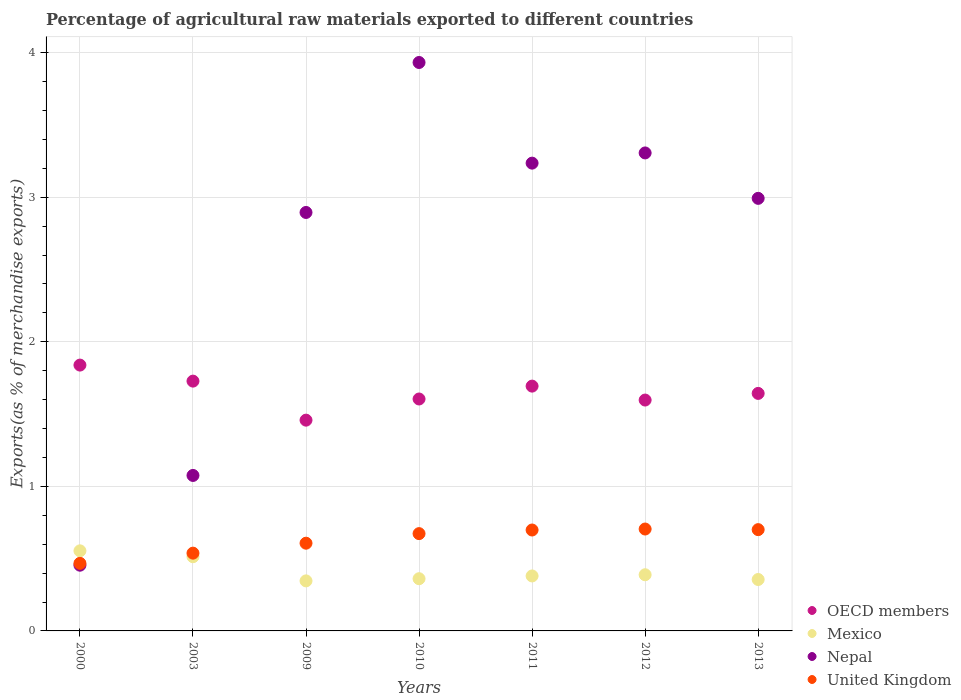What is the percentage of exports to different countries in United Kingdom in 2000?
Your answer should be compact. 0.47. Across all years, what is the maximum percentage of exports to different countries in OECD members?
Give a very brief answer. 1.84. Across all years, what is the minimum percentage of exports to different countries in OECD members?
Offer a terse response. 1.46. What is the total percentage of exports to different countries in Nepal in the graph?
Your answer should be compact. 17.89. What is the difference between the percentage of exports to different countries in United Kingdom in 2010 and that in 2011?
Give a very brief answer. -0.03. What is the difference between the percentage of exports to different countries in OECD members in 2000 and the percentage of exports to different countries in Nepal in 2012?
Offer a terse response. -1.47. What is the average percentage of exports to different countries in United Kingdom per year?
Offer a very short reply. 0.63. In the year 2010, what is the difference between the percentage of exports to different countries in Nepal and percentage of exports to different countries in OECD members?
Offer a terse response. 2.33. In how many years, is the percentage of exports to different countries in Mexico greater than 3.2 %?
Keep it short and to the point. 0. What is the ratio of the percentage of exports to different countries in United Kingdom in 2000 to that in 2011?
Make the answer very short. 0.67. Is the percentage of exports to different countries in United Kingdom in 2009 less than that in 2011?
Offer a terse response. Yes. Is the difference between the percentage of exports to different countries in Nepal in 2003 and 2010 greater than the difference between the percentage of exports to different countries in OECD members in 2003 and 2010?
Offer a terse response. No. What is the difference between the highest and the second highest percentage of exports to different countries in United Kingdom?
Give a very brief answer. 0. What is the difference between the highest and the lowest percentage of exports to different countries in United Kingdom?
Provide a succinct answer. 0.24. How many dotlines are there?
Your answer should be compact. 4. How many years are there in the graph?
Offer a terse response. 7. What is the difference between two consecutive major ticks on the Y-axis?
Provide a succinct answer. 1. Does the graph contain grids?
Keep it short and to the point. Yes. Where does the legend appear in the graph?
Ensure brevity in your answer.  Bottom right. What is the title of the graph?
Your response must be concise. Percentage of agricultural raw materials exported to different countries. Does "Bahrain" appear as one of the legend labels in the graph?
Your response must be concise. No. What is the label or title of the X-axis?
Provide a succinct answer. Years. What is the label or title of the Y-axis?
Your answer should be very brief. Exports(as % of merchandise exports). What is the Exports(as % of merchandise exports) in OECD members in 2000?
Offer a very short reply. 1.84. What is the Exports(as % of merchandise exports) of Mexico in 2000?
Your answer should be compact. 0.55. What is the Exports(as % of merchandise exports) of Nepal in 2000?
Your answer should be very brief. 0.45. What is the Exports(as % of merchandise exports) of United Kingdom in 2000?
Your answer should be very brief. 0.47. What is the Exports(as % of merchandise exports) of OECD members in 2003?
Give a very brief answer. 1.73. What is the Exports(as % of merchandise exports) of Mexico in 2003?
Provide a succinct answer. 0.51. What is the Exports(as % of merchandise exports) of Nepal in 2003?
Ensure brevity in your answer.  1.08. What is the Exports(as % of merchandise exports) of United Kingdom in 2003?
Your answer should be very brief. 0.54. What is the Exports(as % of merchandise exports) of OECD members in 2009?
Offer a terse response. 1.46. What is the Exports(as % of merchandise exports) of Mexico in 2009?
Provide a succinct answer. 0.35. What is the Exports(as % of merchandise exports) in Nepal in 2009?
Make the answer very short. 2.89. What is the Exports(as % of merchandise exports) in United Kingdom in 2009?
Give a very brief answer. 0.61. What is the Exports(as % of merchandise exports) of OECD members in 2010?
Keep it short and to the point. 1.6. What is the Exports(as % of merchandise exports) of Mexico in 2010?
Your answer should be compact. 0.36. What is the Exports(as % of merchandise exports) of Nepal in 2010?
Keep it short and to the point. 3.93. What is the Exports(as % of merchandise exports) of United Kingdom in 2010?
Your response must be concise. 0.67. What is the Exports(as % of merchandise exports) of OECD members in 2011?
Ensure brevity in your answer.  1.69. What is the Exports(as % of merchandise exports) of Mexico in 2011?
Your answer should be compact. 0.38. What is the Exports(as % of merchandise exports) in Nepal in 2011?
Make the answer very short. 3.24. What is the Exports(as % of merchandise exports) of United Kingdom in 2011?
Ensure brevity in your answer.  0.7. What is the Exports(as % of merchandise exports) in OECD members in 2012?
Ensure brevity in your answer.  1.6. What is the Exports(as % of merchandise exports) of Mexico in 2012?
Your answer should be very brief. 0.39. What is the Exports(as % of merchandise exports) in Nepal in 2012?
Keep it short and to the point. 3.31. What is the Exports(as % of merchandise exports) in United Kingdom in 2012?
Your answer should be very brief. 0.7. What is the Exports(as % of merchandise exports) of OECD members in 2013?
Keep it short and to the point. 1.64. What is the Exports(as % of merchandise exports) of Mexico in 2013?
Offer a terse response. 0.36. What is the Exports(as % of merchandise exports) in Nepal in 2013?
Provide a short and direct response. 2.99. What is the Exports(as % of merchandise exports) of United Kingdom in 2013?
Give a very brief answer. 0.7. Across all years, what is the maximum Exports(as % of merchandise exports) of OECD members?
Keep it short and to the point. 1.84. Across all years, what is the maximum Exports(as % of merchandise exports) in Mexico?
Make the answer very short. 0.55. Across all years, what is the maximum Exports(as % of merchandise exports) of Nepal?
Provide a succinct answer. 3.93. Across all years, what is the maximum Exports(as % of merchandise exports) of United Kingdom?
Give a very brief answer. 0.7. Across all years, what is the minimum Exports(as % of merchandise exports) of OECD members?
Offer a very short reply. 1.46. Across all years, what is the minimum Exports(as % of merchandise exports) in Mexico?
Offer a very short reply. 0.35. Across all years, what is the minimum Exports(as % of merchandise exports) of Nepal?
Keep it short and to the point. 0.45. Across all years, what is the minimum Exports(as % of merchandise exports) of United Kingdom?
Your answer should be very brief. 0.47. What is the total Exports(as % of merchandise exports) in OECD members in the graph?
Ensure brevity in your answer.  11.56. What is the total Exports(as % of merchandise exports) of Mexico in the graph?
Provide a short and direct response. 2.9. What is the total Exports(as % of merchandise exports) in Nepal in the graph?
Your response must be concise. 17.89. What is the total Exports(as % of merchandise exports) of United Kingdom in the graph?
Your response must be concise. 4.39. What is the difference between the Exports(as % of merchandise exports) in OECD members in 2000 and that in 2003?
Offer a terse response. 0.11. What is the difference between the Exports(as % of merchandise exports) in Mexico in 2000 and that in 2003?
Offer a very short reply. 0.04. What is the difference between the Exports(as % of merchandise exports) of Nepal in 2000 and that in 2003?
Your response must be concise. -0.62. What is the difference between the Exports(as % of merchandise exports) in United Kingdom in 2000 and that in 2003?
Offer a very short reply. -0.07. What is the difference between the Exports(as % of merchandise exports) of OECD members in 2000 and that in 2009?
Ensure brevity in your answer.  0.38. What is the difference between the Exports(as % of merchandise exports) of Mexico in 2000 and that in 2009?
Provide a succinct answer. 0.21. What is the difference between the Exports(as % of merchandise exports) in Nepal in 2000 and that in 2009?
Give a very brief answer. -2.44. What is the difference between the Exports(as % of merchandise exports) of United Kingdom in 2000 and that in 2009?
Provide a succinct answer. -0.14. What is the difference between the Exports(as % of merchandise exports) in OECD members in 2000 and that in 2010?
Ensure brevity in your answer.  0.23. What is the difference between the Exports(as % of merchandise exports) in Mexico in 2000 and that in 2010?
Make the answer very short. 0.19. What is the difference between the Exports(as % of merchandise exports) in Nepal in 2000 and that in 2010?
Your response must be concise. -3.48. What is the difference between the Exports(as % of merchandise exports) of United Kingdom in 2000 and that in 2010?
Keep it short and to the point. -0.21. What is the difference between the Exports(as % of merchandise exports) in OECD members in 2000 and that in 2011?
Offer a terse response. 0.15. What is the difference between the Exports(as % of merchandise exports) in Mexico in 2000 and that in 2011?
Your answer should be compact. 0.17. What is the difference between the Exports(as % of merchandise exports) of Nepal in 2000 and that in 2011?
Provide a succinct answer. -2.78. What is the difference between the Exports(as % of merchandise exports) in United Kingdom in 2000 and that in 2011?
Provide a short and direct response. -0.23. What is the difference between the Exports(as % of merchandise exports) of OECD members in 2000 and that in 2012?
Offer a terse response. 0.24. What is the difference between the Exports(as % of merchandise exports) in Mexico in 2000 and that in 2012?
Give a very brief answer. 0.17. What is the difference between the Exports(as % of merchandise exports) in Nepal in 2000 and that in 2012?
Your response must be concise. -2.85. What is the difference between the Exports(as % of merchandise exports) of United Kingdom in 2000 and that in 2012?
Offer a very short reply. -0.24. What is the difference between the Exports(as % of merchandise exports) in OECD members in 2000 and that in 2013?
Offer a very short reply. 0.2. What is the difference between the Exports(as % of merchandise exports) of Mexico in 2000 and that in 2013?
Offer a very short reply. 0.2. What is the difference between the Exports(as % of merchandise exports) of Nepal in 2000 and that in 2013?
Keep it short and to the point. -2.54. What is the difference between the Exports(as % of merchandise exports) in United Kingdom in 2000 and that in 2013?
Offer a terse response. -0.23. What is the difference between the Exports(as % of merchandise exports) of OECD members in 2003 and that in 2009?
Offer a terse response. 0.27. What is the difference between the Exports(as % of merchandise exports) in Mexico in 2003 and that in 2009?
Your answer should be compact. 0.17. What is the difference between the Exports(as % of merchandise exports) of Nepal in 2003 and that in 2009?
Offer a terse response. -1.82. What is the difference between the Exports(as % of merchandise exports) of United Kingdom in 2003 and that in 2009?
Provide a succinct answer. -0.07. What is the difference between the Exports(as % of merchandise exports) in OECD members in 2003 and that in 2010?
Your response must be concise. 0.12. What is the difference between the Exports(as % of merchandise exports) of Mexico in 2003 and that in 2010?
Ensure brevity in your answer.  0.15. What is the difference between the Exports(as % of merchandise exports) of Nepal in 2003 and that in 2010?
Your response must be concise. -2.86. What is the difference between the Exports(as % of merchandise exports) of United Kingdom in 2003 and that in 2010?
Provide a short and direct response. -0.14. What is the difference between the Exports(as % of merchandise exports) of OECD members in 2003 and that in 2011?
Provide a succinct answer. 0.03. What is the difference between the Exports(as % of merchandise exports) in Mexico in 2003 and that in 2011?
Offer a terse response. 0.13. What is the difference between the Exports(as % of merchandise exports) of Nepal in 2003 and that in 2011?
Provide a short and direct response. -2.16. What is the difference between the Exports(as % of merchandise exports) in United Kingdom in 2003 and that in 2011?
Keep it short and to the point. -0.16. What is the difference between the Exports(as % of merchandise exports) in OECD members in 2003 and that in 2012?
Make the answer very short. 0.13. What is the difference between the Exports(as % of merchandise exports) of Mexico in 2003 and that in 2012?
Your answer should be very brief. 0.12. What is the difference between the Exports(as % of merchandise exports) in Nepal in 2003 and that in 2012?
Your answer should be compact. -2.23. What is the difference between the Exports(as % of merchandise exports) in United Kingdom in 2003 and that in 2012?
Your answer should be very brief. -0.17. What is the difference between the Exports(as % of merchandise exports) in OECD members in 2003 and that in 2013?
Your response must be concise. 0.09. What is the difference between the Exports(as % of merchandise exports) of Mexico in 2003 and that in 2013?
Give a very brief answer. 0.16. What is the difference between the Exports(as % of merchandise exports) in Nepal in 2003 and that in 2013?
Offer a terse response. -1.92. What is the difference between the Exports(as % of merchandise exports) in United Kingdom in 2003 and that in 2013?
Provide a succinct answer. -0.16. What is the difference between the Exports(as % of merchandise exports) of OECD members in 2009 and that in 2010?
Give a very brief answer. -0.15. What is the difference between the Exports(as % of merchandise exports) in Mexico in 2009 and that in 2010?
Ensure brevity in your answer.  -0.01. What is the difference between the Exports(as % of merchandise exports) in Nepal in 2009 and that in 2010?
Give a very brief answer. -1.04. What is the difference between the Exports(as % of merchandise exports) in United Kingdom in 2009 and that in 2010?
Offer a terse response. -0.07. What is the difference between the Exports(as % of merchandise exports) in OECD members in 2009 and that in 2011?
Provide a short and direct response. -0.24. What is the difference between the Exports(as % of merchandise exports) of Mexico in 2009 and that in 2011?
Give a very brief answer. -0.03. What is the difference between the Exports(as % of merchandise exports) in Nepal in 2009 and that in 2011?
Keep it short and to the point. -0.34. What is the difference between the Exports(as % of merchandise exports) in United Kingdom in 2009 and that in 2011?
Offer a terse response. -0.09. What is the difference between the Exports(as % of merchandise exports) of OECD members in 2009 and that in 2012?
Provide a short and direct response. -0.14. What is the difference between the Exports(as % of merchandise exports) in Mexico in 2009 and that in 2012?
Keep it short and to the point. -0.04. What is the difference between the Exports(as % of merchandise exports) of Nepal in 2009 and that in 2012?
Offer a very short reply. -0.41. What is the difference between the Exports(as % of merchandise exports) in United Kingdom in 2009 and that in 2012?
Make the answer very short. -0.1. What is the difference between the Exports(as % of merchandise exports) in OECD members in 2009 and that in 2013?
Offer a very short reply. -0.18. What is the difference between the Exports(as % of merchandise exports) of Mexico in 2009 and that in 2013?
Provide a short and direct response. -0.01. What is the difference between the Exports(as % of merchandise exports) of Nepal in 2009 and that in 2013?
Your answer should be very brief. -0.1. What is the difference between the Exports(as % of merchandise exports) of United Kingdom in 2009 and that in 2013?
Keep it short and to the point. -0.09. What is the difference between the Exports(as % of merchandise exports) in OECD members in 2010 and that in 2011?
Provide a short and direct response. -0.09. What is the difference between the Exports(as % of merchandise exports) in Mexico in 2010 and that in 2011?
Provide a succinct answer. -0.02. What is the difference between the Exports(as % of merchandise exports) of Nepal in 2010 and that in 2011?
Ensure brevity in your answer.  0.7. What is the difference between the Exports(as % of merchandise exports) in United Kingdom in 2010 and that in 2011?
Keep it short and to the point. -0.03. What is the difference between the Exports(as % of merchandise exports) in OECD members in 2010 and that in 2012?
Your response must be concise. 0.01. What is the difference between the Exports(as % of merchandise exports) in Mexico in 2010 and that in 2012?
Your response must be concise. -0.03. What is the difference between the Exports(as % of merchandise exports) of Nepal in 2010 and that in 2012?
Provide a succinct answer. 0.63. What is the difference between the Exports(as % of merchandise exports) in United Kingdom in 2010 and that in 2012?
Provide a short and direct response. -0.03. What is the difference between the Exports(as % of merchandise exports) in OECD members in 2010 and that in 2013?
Make the answer very short. -0.04. What is the difference between the Exports(as % of merchandise exports) of Mexico in 2010 and that in 2013?
Make the answer very short. 0.01. What is the difference between the Exports(as % of merchandise exports) in Nepal in 2010 and that in 2013?
Your response must be concise. 0.94. What is the difference between the Exports(as % of merchandise exports) of United Kingdom in 2010 and that in 2013?
Ensure brevity in your answer.  -0.03. What is the difference between the Exports(as % of merchandise exports) of OECD members in 2011 and that in 2012?
Your answer should be compact. 0.1. What is the difference between the Exports(as % of merchandise exports) in Mexico in 2011 and that in 2012?
Offer a very short reply. -0.01. What is the difference between the Exports(as % of merchandise exports) of Nepal in 2011 and that in 2012?
Provide a short and direct response. -0.07. What is the difference between the Exports(as % of merchandise exports) in United Kingdom in 2011 and that in 2012?
Offer a terse response. -0.01. What is the difference between the Exports(as % of merchandise exports) in OECD members in 2011 and that in 2013?
Your response must be concise. 0.05. What is the difference between the Exports(as % of merchandise exports) in Mexico in 2011 and that in 2013?
Your answer should be very brief. 0.02. What is the difference between the Exports(as % of merchandise exports) in Nepal in 2011 and that in 2013?
Make the answer very short. 0.24. What is the difference between the Exports(as % of merchandise exports) in United Kingdom in 2011 and that in 2013?
Give a very brief answer. -0. What is the difference between the Exports(as % of merchandise exports) in OECD members in 2012 and that in 2013?
Give a very brief answer. -0.05. What is the difference between the Exports(as % of merchandise exports) in Mexico in 2012 and that in 2013?
Your response must be concise. 0.03. What is the difference between the Exports(as % of merchandise exports) in Nepal in 2012 and that in 2013?
Your answer should be very brief. 0.31. What is the difference between the Exports(as % of merchandise exports) of United Kingdom in 2012 and that in 2013?
Your response must be concise. 0. What is the difference between the Exports(as % of merchandise exports) of OECD members in 2000 and the Exports(as % of merchandise exports) of Mexico in 2003?
Your answer should be very brief. 1.33. What is the difference between the Exports(as % of merchandise exports) in OECD members in 2000 and the Exports(as % of merchandise exports) in Nepal in 2003?
Offer a terse response. 0.76. What is the difference between the Exports(as % of merchandise exports) in OECD members in 2000 and the Exports(as % of merchandise exports) in United Kingdom in 2003?
Offer a terse response. 1.3. What is the difference between the Exports(as % of merchandise exports) in Mexico in 2000 and the Exports(as % of merchandise exports) in Nepal in 2003?
Give a very brief answer. -0.52. What is the difference between the Exports(as % of merchandise exports) in Mexico in 2000 and the Exports(as % of merchandise exports) in United Kingdom in 2003?
Your answer should be compact. 0.02. What is the difference between the Exports(as % of merchandise exports) in Nepal in 2000 and the Exports(as % of merchandise exports) in United Kingdom in 2003?
Provide a succinct answer. -0.08. What is the difference between the Exports(as % of merchandise exports) in OECD members in 2000 and the Exports(as % of merchandise exports) in Mexico in 2009?
Your answer should be compact. 1.49. What is the difference between the Exports(as % of merchandise exports) in OECD members in 2000 and the Exports(as % of merchandise exports) in Nepal in 2009?
Ensure brevity in your answer.  -1.06. What is the difference between the Exports(as % of merchandise exports) of OECD members in 2000 and the Exports(as % of merchandise exports) of United Kingdom in 2009?
Provide a succinct answer. 1.23. What is the difference between the Exports(as % of merchandise exports) in Mexico in 2000 and the Exports(as % of merchandise exports) in Nepal in 2009?
Give a very brief answer. -2.34. What is the difference between the Exports(as % of merchandise exports) of Mexico in 2000 and the Exports(as % of merchandise exports) of United Kingdom in 2009?
Your response must be concise. -0.05. What is the difference between the Exports(as % of merchandise exports) of Nepal in 2000 and the Exports(as % of merchandise exports) of United Kingdom in 2009?
Provide a succinct answer. -0.15. What is the difference between the Exports(as % of merchandise exports) of OECD members in 2000 and the Exports(as % of merchandise exports) of Mexico in 2010?
Provide a succinct answer. 1.48. What is the difference between the Exports(as % of merchandise exports) of OECD members in 2000 and the Exports(as % of merchandise exports) of Nepal in 2010?
Your answer should be compact. -2.09. What is the difference between the Exports(as % of merchandise exports) in OECD members in 2000 and the Exports(as % of merchandise exports) in United Kingdom in 2010?
Keep it short and to the point. 1.17. What is the difference between the Exports(as % of merchandise exports) of Mexico in 2000 and the Exports(as % of merchandise exports) of Nepal in 2010?
Ensure brevity in your answer.  -3.38. What is the difference between the Exports(as % of merchandise exports) of Mexico in 2000 and the Exports(as % of merchandise exports) of United Kingdom in 2010?
Your answer should be compact. -0.12. What is the difference between the Exports(as % of merchandise exports) of Nepal in 2000 and the Exports(as % of merchandise exports) of United Kingdom in 2010?
Your response must be concise. -0.22. What is the difference between the Exports(as % of merchandise exports) of OECD members in 2000 and the Exports(as % of merchandise exports) of Mexico in 2011?
Provide a succinct answer. 1.46. What is the difference between the Exports(as % of merchandise exports) in OECD members in 2000 and the Exports(as % of merchandise exports) in Nepal in 2011?
Make the answer very short. -1.4. What is the difference between the Exports(as % of merchandise exports) in OECD members in 2000 and the Exports(as % of merchandise exports) in United Kingdom in 2011?
Ensure brevity in your answer.  1.14. What is the difference between the Exports(as % of merchandise exports) of Mexico in 2000 and the Exports(as % of merchandise exports) of Nepal in 2011?
Offer a terse response. -2.68. What is the difference between the Exports(as % of merchandise exports) in Mexico in 2000 and the Exports(as % of merchandise exports) in United Kingdom in 2011?
Provide a succinct answer. -0.14. What is the difference between the Exports(as % of merchandise exports) of Nepal in 2000 and the Exports(as % of merchandise exports) of United Kingdom in 2011?
Offer a terse response. -0.24. What is the difference between the Exports(as % of merchandise exports) in OECD members in 2000 and the Exports(as % of merchandise exports) in Mexico in 2012?
Keep it short and to the point. 1.45. What is the difference between the Exports(as % of merchandise exports) of OECD members in 2000 and the Exports(as % of merchandise exports) of Nepal in 2012?
Make the answer very short. -1.47. What is the difference between the Exports(as % of merchandise exports) in OECD members in 2000 and the Exports(as % of merchandise exports) in United Kingdom in 2012?
Your answer should be very brief. 1.13. What is the difference between the Exports(as % of merchandise exports) in Mexico in 2000 and the Exports(as % of merchandise exports) in Nepal in 2012?
Offer a terse response. -2.75. What is the difference between the Exports(as % of merchandise exports) of Mexico in 2000 and the Exports(as % of merchandise exports) of United Kingdom in 2012?
Keep it short and to the point. -0.15. What is the difference between the Exports(as % of merchandise exports) in Nepal in 2000 and the Exports(as % of merchandise exports) in United Kingdom in 2012?
Provide a short and direct response. -0.25. What is the difference between the Exports(as % of merchandise exports) in OECD members in 2000 and the Exports(as % of merchandise exports) in Mexico in 2013?
Offer a terse response. 1.48. What is the difference between the Exports(as % of merchandise exports) in OECD members in 2000 and the Exports(as % of merchandise exports) in Nepal in 2013?
Your response must be concise. -1.15. What is the difference between the Exports(as % of merchandise exports) in OECD members in 2000 and the Exports(as % of merchandise exports) in United Kingdom in 2013?
Offer a terse response. 1.14. What is the difference between the Exports(as % of merchandise exports) in Mexico in 2000 and the Exports(as % of merchandise exports) in Nepal in 2013?
Provide a succinct answer. -2.44. What is the difference between the Exports(as % of merchandise exports) of Mexico in 2000 and the Exports(as % of merchandise exports) of United Kingdom in 2013?
Provide a succinct answer. -0.15. What is the difference between the Exports(as % of merchandise exports) of Nepal in 2000 and the Exports(as % of merchandise exports) of United Kingdom in 2013?
Your response must be concise. -0.25. What is the difference between the Exports(as % of merchandise exports) in OECD members in 2003 and the Exports(as % of merchandise exports) in Mexico in 2009?
Your answer should be compact. 1.38. What is the difference between the Exports(as % of merchandise exports) in OECD members in 2003 and the Exports(as % of merchandise exports) in Nepal in 2009?
Keep it short and to the point. -1.17. What is the difference between the Exports(as % of merchandise exports) of OECD members in 2003 and the Exports(as % of merchandise exports) of United Kingdom in 2009?
Give a very brief answer. 1.12. What is the difference between the Exports(as % of merchandise exports) of Mexico in 2003 and the Exports(as % of merchandise exports) of Nepal in 2009?
Your answer should be compact. -2.38. What is the difference between the Exports(as % of merchandise exports) of Mexico in 2003 and the Exports(as % of merchandise exports) of United Kingdom in 2009?
Your answer should be compact. -0.09. What is the difference between the Exports(as % of merchandise exports) of Nepal in 2003 and the Exports(as % of merchandise exports) of United Kingdom in 2009?
Make the answer very short. 0.47. What is the difference between the Exports(as % of merchandise exports) in OECD members in 2003 and the Exports(as % of merchandise exports) in Mexico in 2010?
Give a very brief answer. 1.37. What is the difference between the Exports(as % of merchandise exports) in OECD members in 2003 and the Exports(as % of merchandise exports) in Nepal in 2010?
Ensure brevity in your answer.  -2.2. What is the difference between the Exports(as % of merchandise exports) in OECD members in 2003 and the Exports(as % of merchandise exports) in United Kingdom in 2010?
Provide a succinct answer. 1.05. What is the difference between the Exports(as % of merchandise exports) in Mexico in 2003 and the Exports(as % of merchandise exports) in Nepal in 2010?
Offer a very short reply. -3.42. What is the difference between the Exports(as % of merchandise exports) of Mexico in 2003 and the Exports(as % of merchandise exports) of United Kingdom in 2010?
Your response must be concise. -0.16. What is the difference between the Exports(as % of merchandise exports) of Nepal in 2003 and the Exports(as % of merchandise exports) of United Kingdom in 2010?
Provide a short and direct response. 0.4. What is the difference between the Exports(as % of merchandise exports) in OECD members in 2003 and the Exports(as % of merchandise exports) in Mexico in 2011?
Make the answer very short. 1.35. What is the difference between the Exports(as % of merchandise exports) of OECD members in 2003 and the Exports(as % of merchandise exports) of Nepal in 2011?
Your response must be concise. -1.51. What is the difference between the Exports(as % of merchandise exports) of OECD members in 2003 and the Exports(as % of merchandise exports) of United Kingdom in 2011?
Offer a terse response. 1.03. What is the difference between the Exports(as % of merchandise exports) of Mexico in 2003 and the Exports(as % of merchandise exports) of Nepal in 2011?
Make the answer very short. -2.72. What is the difference between the Exports(as % of merchandise exports) in Mexico in 2003 and the Exports(as % of merchandise exports) in United Kingdom in 2011?
Provide a short and direct response. -0.18. What is the difference between the Exports(as % of merchandise exports) of Nepal in 2003 and the Exports(as % of merchandise exports) of United Kingdom in 2011?
Your answer should be very brief. 0.38. What is the difference between the Exports(as % of merchandise exports) in OECD members in 2003 and the Exports(as % of merchandise exports) in Mexico in 2012?
Provide a succinct answer. 1.34. What is the difference between the Exports(as % of merchandise exports) of OECD members in 2003 and the Exports(as % of merchandise exports) of Nepal in 2012?
Your answer should be compact. -1.58. What is the difference between the Exports(as % of merchandise exports) of OECD members in 2003 and the Exports(as % of merchandise exports) of United Kingdom in 2012?
Make the answer very short. 1.02. What is the difference between the Exports(as % of merchandise exports) of Mexico in 2003 and the Exports(as % of merchandise exports) of Nepal in 2012?
Ensure brevity in your answer.  -2.79. What is the difference between the Exports(as % of merchandise exports) in Mexico in 2003 and the Exports(as % of merchandise exports) in United Kingdom in 2012?
Keep it short and to the point. -0.19. What is the difference between the Exports(as % of merchandise exports) in Nepal in 2003 and the Exports(as % of merchandise exports) in United Kingdom in 2012?
Give a very brief answer. 0.37. What is the difference between the Exports(as % of merchandise exports) in OECD members in 2003 and the Exports(as % of merchandise exports) in Mexico in 2013?
Offer a terse response. 1.37. What is the difference between the Exports(as % of merchandise exports) in OECD members in 2003 and the Exports(as % of merchandise exports) in Nepal in 2013?
Offer a very short reply. -1.26. What is the difference between the Exports(as % of merchandise exports) in OECD members in 2003 and the Exports(as % of merchandise exports) in United Kingdom in 2013?
Keep it short and to the point. 1.03. What is the difference between the Exports(as % of merchandise exports) in Mexico in 2003 and the Exports(as % of merchandise exports) in Nepal in 2013?
Give a very brief answer. -2.48. What is the difference between the Exports(as % of merchandise exports) in Mexico in 2003 and the Exports(as % of merchandise exports) in United Kingdom in 2013?
Make the answer very short. -0.19. What is the difference between the Exports(as % of merchandise exports) of Nepal in 2003 and the Exports(as % of merchandise exports) of United Kingdom in 2013?
Offer a very short reply. 0.37. What is the difference between the Exports(as % of merchandise exports) of OECD members in 2009 and the Exports(as % of merchandise exports) of Mexico in 2010?
Your response must be concise. 1.1. What is the difference between the Exports(as % of merchandise exports) in OECD members in 2009 and the Exports(as % of merchandise exports) in Nepal in 2010?
Provide a short and direct response. -2.47. What is the difference between the Exports(as % of merchandise exports) of OECD members in 2009 and the Exports(as % of merchandise exports) of United Kingdom in 2010?
Ensure brevity in your answer.  0.79. What is the difference between the Exports(as % of merchandise exports) in Mexico in 2009 and the Exports(as % of merchandise exports) in Nepal in 2010?
Provide a succinct answer. -3.59. What is the difference between the Exports(as % of merchandise exports) in Mexico in 2009 and the Exports(as % of merchandise exports) in United Kingdom in 2010?
Ensure brevity in your answer.  -0.33. What is the difference between the Exports(as % of merchandise exports) of Nepal in 2009 and the Exports(as % of merchandise exports) of United Kingdom in 2010?
Ensure brevity in your answer.  2.22. What is the difference between the Exports(as % of merchandise exports) of OECD members in 2009 and the Exports(as % of merchandise exports) of Mexico in 2011?
Your response must be concise. 1.08. What is the difference between the Exports(as % of merchandise exports) of OECD members in 2009 and the Exports(as % of merchandise exports) of Nepal in 2011?
Ensure brevity in your answer.  -1.78. What is the difference between the Exports(as % of merchandise exports) in OECD members in 2009 and the Exports(as % of merchandise exports) in United Kingdom in 2011?
Give a very brief answer. 0.76. What is the difference between the Exports(as % of merchandise exports) of Mexico in 2009 and the Exports(as % of merchandise exports) of Nepal in 2011?
Your answer should be very brief. -2.89. What is the difference between the Exports(as % of merchandise exports) in Mexico in 2009 and the Exports(as % of merchandise exports) in United Kingdom in 2011?
Give a very brief answer. -0.35. What is the difference between the Exports(as % of merchandise exports) in Nepal in 2009 and the Exports(as % of merchandise exports) in United Kingdom in 2011?
Ensure brevity in your answer.  2.2. What is the difference between the Exports(as % of merchandise exports) of OECD members in 2009 and the Exports(as % of merchandise exports) of Mexico in 2012?
Offer a terse response. 1.07. What is the difference between the Exports(as % of merchandise exports) of OECD members in 2009 and the Exports(as % of merchandise exports) of Nepal in 2012?
Make the answer very short. -1.85. What is the difference between the Exports(as % of merchandise exports) in OECD members in 2009 and the Exports(as % of merchandise exports) in United Kingdom in 2012?
Keep it short and to the point. 0.75. What is the difference between the Exports(as % of merchandise exports) in Mexico in 2009 and the Exports(as % of merchandise exports) in Nepal in 2012?
Your response must be concise. -2.96. What is the difference between the Exports(as % of merchandise exports) of Mexico in 2009 and the Exports(as % of merchandise exports) of United Kingdom in 2012?
Keep it short and to the point. -0.36. What is the difference between the Exports(as % of merchandise exports) of Nepal in 2009 and the Exports(as % of merchandise exports) of United Kingdom in 2012?
Your response must be concise. 2.19. What is the difference between the Exports(as % of merchandise exports) of OECD members in 2009 and the Exports(as % of merchandise exports) of Mexico in 2013?
Keep it short and to the point. 1.1. What is the difference between the Exports(as % of merchandise exports) of OECD members in 2009 and the Exports(as % of merchandise exports) of Nepal in 2013?
Offer a terse response. -1.53. What is the difference between the Exports(as % of merchandise exports) of OECD members in 2009 and the Exports(as % of merchandise exports) of United Kingdom in 2013?
Offer a very short reply. 0.76. What is the difference between the Exports(as % of merchandise exports) in Mexico in 2009 and the Exports(as % of merchandise exports) in Nepal in 2013?
Ensure brevity in your answer.  -2.65. What is the difference between the Exports(as % of merchandise exports) in Mexico in 2009 and the Exports(as % of merchandise exports) in United Kingdom in 2013?
Keep it short and to the point. -0.35. What is the difference between the Exports(as % of merchandise exports) in Nepal in 2009 and the Exports(as % of merchandise exports) in United Kingdom in 2013?
Offer a very short reply. 2.19. What is the difference between the Exports(as % of merchandise exports) in OECD members in 2010 and the Exports(as % of merchandise exports) in Mexico in 2011?
Provide a short and direct response. 1.22. What is the difference between the Exports(as % of merchandise exports) of OECD members in 2010 and the Exports(as % of merchandise exports) of Nepal in 2011?
Give a very brief answer. -1.63. What is the difference between the Exports(as % of merchandise exports) of OECD members in 2010 and the Exports(as % of merchandise exports) of United Kingdom in 2011?
Provide a succinct answer. 0.91. What is the difference between the Exports(as % of merchandise exports) of Mexico in 2010 and the Exports(as % of merchandise exports) of Nepal in 2011?
Ensure brevity in your answer.  -2.87. What is the difference between the Exports(as % of merchandise exports) in Mexico in 2010 and the Exports(as % of merchandise exports) in United Kingdom in 2011?
Your answer should be compact. -0.34. What is the difference between the Exports(as % of merchandise exports) in Nepal in 2010 and the Exports(as % of merchandise exports) in United Kingdom in 2011?
Offer a very short reply. 3.23. What is the difference between the Exports(as % of merchandise exports) of OECD members in 2010 and the Exports(as % of merchandise exports) of Mexico in 2012?
Provide a short and direct response. 1.22. What is the difference between the Exports(as % of merchandise exports) in OECD members in 2010 and the Exports(as % of merchandise exports) in Nepal in 2012?
Give a very brief answer. -1.7. What is the difference between the Exports(as % of merchandise exports) of OECD members in 2010 and the Exports(as % of merchandise exports) of United Kingdom in 2012?
Make the answer very short. 0.9. What is the difference between the Exports(as % of merchandise exports) of Mexico in 2010 and the Exports(as % of merchandise exports) of Nepal in 2012?
Keep it short and to the point. -2.95. What is the difference between the Exports(as % of merchandise exports) in Mexico in 2010 and the Exports(as % of merchandise exports) in United Kingdom in 2012?
Provide a succinct answer. -0.34. What is the difference between the Exports(as % of merchandise exports) in Nepal in 2010 and the Exports(as % of merchandise exports) in United Kingdom in 2012?
Give a very brief answer. 3.23. What is the difference between the Exports(as % of merchandise exports) in OECD members in 2010 and the Exports(as % of merchandise exports) in Mexico in 2013?
Your answer should be compact. 1.25. What is the difference between the Exports(as % of merchandise exports) in OECD members in 2010 and the Exports(as % of merchandise exports) in Nepal in 2013?
Provide a succinct answer. -1.39. What is the difference between the Exports(as % of merchandise exports) of OECD members in 2010 and the Exports(as % of merchandise exports) of United Kingdom in 2013?
Your answer should be very brief. 0.9. What is the difference between the Exports(as % of merchandise exports) of Mexico in 2010 and the Exports(as % of merchandise exports) of Nepal in 2013?
Provide a short and direct response. -2.63. What is the difference between the Exports(as % of merchandise exports) of Mexico in 2010 and the Exports(as % of merchandise exports) of United Kingdom in 2013?
Your answer should be very brief. -0.34. What is the difference between the Exports(as % of merchandise exports) in Nepal in 2010 and the Exports(as % of merchandise exports) in United Kingdom in 2013?
Keep it short and to the point. 3.23. What is the difference between the Exports(as % of merchandise exports) in OECD members in 2011 and the Exports(as % of merchandise exports) in Mexico in 2012?
Make the answer very short. 1.3. What is the difference between the Exports(as % of merchandise exports) of OECD members in 2011 and the Exports(as % of merchandise exports) of Nepal in 2012?
Make the answer very short. -1.61. What is the difference between the Exports(as % of merchandise exports) of Mexico in 2011 and the Exports(as % of merchandise exports) of Nepal in 2012?
Ensure brevity in your answer.  -2.93. What is the difference between the Exports(as % of merchandise exports) of Mexico in 2011 and the Exports(as % of merchandise exports) of United Kingdom in 2012?
Your answer should be compact. -0.32. What is the difference between the Exports(as % of merchandise exports) of Nepal in 2011 and the Exports(as % of merchandise exports) of United Kingdom in 2012?
Provide a succinct answer. 2.53. What is the difference between the Exports(as % of merchandise exports) of OECD members in 2011 and the Exports(as % of merchandise exports) of Mexico in 2013?
Provide a short and direct response. 1.34. What is the difference between the Exports(as % of merchandise exports) in OECD members in 2011 and the Exports(as % of merchandise exports) in Nepal in 2013?
Provide a short and direct response. -1.3. What is the difference between the Exports(as % of merchandise exports) in Mexico in 2011 and the Exports(as % of merchandise exports) in Nepal in 2013?
Your answer should be very brief. -2.61. What is the difference between the Exports(as % of merchandise exports) in Mexico in 2011 and the Exports(as % of merchandise exports) in United Kingdom in 2013?
Provide a succinct answer. -0.32. What is the difference between the Exports(as % of merchandise exports) in Nepal in 2011 and the Exports(as % of merchandise exports) in United Kingdom in 2013?
Your response must be concise. 2.54. What is the difference between the Exports(as % of merchandise exports) in OECD members in 2012 and the Exports(as % of merchandise exports) in Mexico in 2013?
Your response must be concise. 1.24. What is the difference between the Exports(as % of merchandise exports) of OECD members in 2012 and the Exports(as % of merchandise exports) of Nepal in 2013?
Offer a terse response. -1.4. What is the difference between the Exports(as % of merchandise exports) of OECD members in 2012 and the Exports(as % of merchandise exports) of United Kingdom in 2013?
Keep it short and to the point. 0.9. What is the difference between the Exports(as % of merchandise exports) in Mexico in 2012 and the Exports(as % of merchandise exports) in Nepal in 2013?
Offer a very short reply. -2.6. What is the difference between the Exports(as % of merchandise exports) of Mexico in 2012 and the Exports(as % of merchandise exports) of United Kingdom in 2013?
Ensure brevity in your answer.  -0.31. What is the difference between the Exports(as % of merchandise exports) of Nepal in 2012 and the Exports(as % of merchandise exports) of United Kingdom in 2013?
Ensure brevity in your answer.  2.61. What is the average Exports(as % of merchandise exports) in OECD members per year?
Keep it short and to the point. 1.65. What is the average Exports(as % of merchandise exports) in Mexico per year?
Offer a very short reply. 0.41. What is the average Exports(as % of merchandise exports) of Nepal per year?
Provide a succinct answer. 2.56. What is the average Exports(as % of merchandise exports) of United Kingdom per year?
Your answer should be very brief. 0.63. In the year 2000, what is the difference between the Exports(as % of merchandise exports) in OECD members and Exports(as % of merchandise exports) in Mexico?
Give a very brief answer. 1.28. In the year 2000, what is the difference between the Exports(as % of merchandise exports) of OECD members and Exports(as % of merchandise exports) of Nepal?
Provide a succinct answer. 1.38. In the year 2000, what is the difference between the Exports(as % of merchandise exports) of OECD members and Exports(as % of merchandise exports) of United Kingdom?
Offer a very short reply. 1.37. In the year 2000, what is the difference between the Exports(as % of merchandise exports) in Mexico and Exports(as % of merchandise exports) in Nepal?
Make the answer very short. 0.1. In the year 2000, what is the difference between the Exports(as % of merchandise exports) in Mexico and Exports(as % of merchandise exports) in United Kingdom?
Offer a terse response. 0.09. In the year 2000, what is the difference between the Exports(as % of merchandise exports) of Nepal and Exports(as % of merchandise exports) of United Kingdom?
Offer a very short reply. -0.01. In the year 2003, what is the difference between the Exports(as % of merchandise exports) of OECD members and Exports(as % of merchandise exports) of Mexico?
Provide a short and direct response. 1.21. In the year 2003, what is the difference between the Exports(as % of merchandise exports) in OECD members and Exports(as % of merchandise exports) in Nepal?
Your answer should be very brief. 0.65. In the year 2003, what is the difference between the Exports(as % of merchandise exports) of OECD members and Exports(as % of merchandise exports) of United Kingdom?
Give a very brief answer. 1.19. In the year 2003, what is the difference between the Exports(as % of merchandise exports) of Mexico and Exports(as % of merchandise exports) of Nepal?
Keep it short and to the point. -0.56. In the year 2003, what is the difference between the Exports(as % of merchandise exports) in Mexico and Exports(as % of merchandise exports) in United Kingdom?
Provide a short and direct response. -0.02. In the year 2003, what is the difference between the Exports(as % of merchandise exports) in Nepal and Exports(as % of merchandise exports) in United Kingdom?
Your response must be concise. 0.54. In the year 2009, what is the difference between the Exports(as % of merchandise exports) in OECD members and Exports(as % of merchandise exports) in Mexico?
Your answer should be compact. 1.11. In the year 2009, what is the difference between the Exports(as % of merchandise exports) in OECD members and Exports(as % of merchandise exports) in Nepal?
Make the answer very short. -1.44. In the year 2009, what is the difference between the Exports(as % of merchandise exports) of OECD members and Exports(as % of merchandise exports) of United Kingdom?
Make the answer very short. 0.85. In the year 2009, what is the difference between the Exports(as % of merchandise exports) in Mexico and Exports(as % of merchandise exports) in Nepal?
Keep it short and to the point. -2.55. In the year 2009, what is the difference between the Exports(as % of merchandise exports) of Mexico and Exports(as % of merchandise exports) of United Kingdom?
Make the answer very short. -0.26. In the year 2009, what is the difference between the Exports(as % of merchandise exports) of Nepal and Exports(as % of merchandise exports) of United Kingdom?
Make the answer very short. 2.29. In the year 2010, what is the difference between the Exports(as % of merchandise exports) of OECD members and Exports(as % of merchandise exports) of Mexico?
Offer a terse response. 1.24. In the year 2010, what is the difference between the Exports(as % of merchandise exports) in OECD members and Exports(as % of merchandise exports) in Nepal?
Offer a terse response. -2.33. In the year 2010, what is the difference between the Exports(as % of merchandise exports) of OECD members and Exports(as % of merchandise exports) of United Kingdom?
Provide a short and direct response. 0.93. In the year 2010, what is the difference between the Exports(as % of merchandise exports) of Mexico and Exports(as % of merchandise exports) of Nepal?
Provide a short and direct response. -3.57. In the year 2010, what is the difference between the Exports(as % of merchandise exports) of Mexico and Exports(as % of merchandise exports) of United Kingdom?
Ensure brevity in your answer.  -0.31. In the year 2010, what is the difference between the Exports(as % of merchandise exports) of Nepal and Exports(as % of merchandise exports) of United Kingdom?
Provide a short and direct response. 3.26. In the year 2011, what is the difference between the Exports(as % of merchandise exports) of OECD members and Exports(as % of merchandise exports) of Mexico?
Keep it short and to the point. 1.31. In the year 2011, what is the difference between the Exports(as % of merchandise exports) of OECD members and Exports(as % of merchandise exports) of Nepal?
Provide a short and direct response. -1.54. In the year 2011, what is the difference between the Exports(as % of merchandise exports) of OECD members and Exports(as % of merchandise exports) of United Kingdom?
Give a very brief answer. 1. In the year 2011, what is the difference between the Exports(as % of merchandise exports) in Mexico and Exports(as % of merchandise exports) in Nepal?
Your answer should be compact. -2.86. In the year 2011, what is the difference between the Exports(as % of merchandise exports) of Mexico and Exports(as % of merchandise exports) of United Kingdom?
Your response must be concise. -0.32. In the year 2011, what is the difference between the Exports(as % of merchandise exports) in Nepal and Exports(as % of merchandise exports) in United Kingdom?
Ensure brevity in your answer.  2.54. In the year 2012, what is the difference between the Exports(as % of merchandise exports) in OECD members and Exports(as % of merchandise exports) in Mexico?
Keep it short and to the point. 1.21. In the year 2012, what is the difference between the Exports(as % of merchandise exports) of OECD members and Exports(as % of merchandise exports) of Nepal?
Your answer should be compact. -1.71. In the year 2012, what is the difference between the Exports(as % of merchandise exports) in OECD members and Exports(as % of merchandise exports) in United Kingdom?
Your answer should be very brief. 0.89. In the year 2012, what is the difference between the Exports(as % of merchandise exports) of Mexico and Exports(as % of merchandise exports) of Nepal?
Keep it short and to the point. -2.92. In the year 2012, what is the difference between the Exports(as % of merchandise exports) in Mexico and Exports(as % of merchandise exports) in United Kingdom?
Provide a succinct answer. -0.32. In the year 2012, what is the difference between the Exports(as % of merchandise exports) in Nepal and Exports(as % of merchandise exports) in United Kingdom?
Make the answer very short. 2.6. In the year 2013, what is the difference between the Exports(as % of merchandise exports) of OECD members and Exports(as % of merchandise exports) of Mexico?
Your response must be concise. 1.29. In the year 2013, what is the difference between the Exports(as % of merchandise exports) in OECD members and Exports(as % of merchandise exports) in Nepal?
Keep it short and to the point. -1.35. In the year 2013, what is the difference between the Exports(as % of merchandise exports) of OECD members and Exports(as % of merchandise exports) of United Kingdom?
Your response must be concise. 0.94. In the year 2013, what is the difference between the Exports(as % of merchandise exports) of Mexico and Exports(as % of merchandise exports) of Nepal?
Your response must be concise. -2.64. In the year 2013, what is the difference between the Exports(as % of merchandise exports) of Mexico and Exports(as % of merchandise exports) of United Kingdom?
Keep it short and to the point. -0.34. In the year 2013, what is the difference between the Exports(as % of merchandise exports) of Nepal and Exports(as % of merchandise exports) of United Kingdom?
Ensure brevity in your answer.  2.29. What is the ratio of the Exports(as % of merchandise exports) in OECD members in 2000 to that in 2003?
Provide a succinct answer. 1.06. What is the ratio of the Exports(as % of merchandise exports) of Mexico in 2000 to that in 2003?
Keep it short and to the point. 1.08. What is the ratio of the Exports(as % of merchandise exports) of Nepal in 2000 to that in 2003?
Ensure brevity in your answer.  0.42. What is the ratio of the Exports(as % of merchandise exports) in United Kingdom in 2000 to that in 2003?
Provide a short and direct response. 0.87. What is the ratio of the Exports(as % of merchandise exports) of OECD members in 2000 to that in 2009?
Offer a very short reply. 1.26. What is the ratio of the Exports(as % of merchandise exports) of Mexico in 2000 to that in 2009?
Your response must be concise. 1.6. What is the ratio of the Exports(as % of merchandise exports) in Nepal in 2000 to that in 2009?
Your answer should be very brief. 0.16. What is the ratio of the Exports(as % of merchandise exports) in United Kingdom in 2000 to that in 2009?
Your answer should be very brief. 0.77. What is the ratio of the Exports(as % of merchandise exports) in OECD members in 2000 to that in 2010?
Give a very brief answer. 1.15. What is the ratio of the Exports(as % of merchandise exports) in Mexico in 2000 to that in 2010?
Provide a short and direct response. 1.53. What is the ratio of the Exports(as % of merchandise exports) in Nepal in 2000 to that in 2010?
Keep it short and to the point. 0.12. What is the ratio of the Exports(as % of merchandise exports) of United Kingdom in 2000 to that in 2010?
Your response must be concise. 0.69. What is the ratio of the Exports(as % of merchandise exports) in OECD members in 2000 to that in 2011?
Your answer should be very brief. 1.09. What is the ratio of the Exports(as % of merchandise exports) of Mexico in 2000 to that in 2011?
Make the answer very short. 1.46. What is the ratio of the Exports(as % of merchandise exports) in Nepal in 2000 to that in 2011?
Provide a short and direct response. 0.14. What is the ratio of the Exports(as % of merchandise exports) of United Kingdom in 2000 to that in 2011?
Give a very brief answer. 0.67. What is the ratio of the Exports(as % of merchandise exports) of OECD members in 2000 to that in 2012?
Provide a short and direct response. 1.15. What is the ratio of the Exports(as % of merchandise exports) in Mexico in 2000 to that in 2012?
Make the answer very short. 1.43. What is the ratio of the Exports(as % of merchandise exports) of Nepal in 2000 to that in 2012?
Keep it short and to the point. 0.14. What is the ratio of the Exports(as % of merchandise exports) of United Kingdom in 2000 to that in 2012?
Give a very brief answer. 0.66. What is the ratio of the Exports(as % of merchandise exports) of OECD members in 2000 to that in 2013?
Provide a succinct answer. 1.12. What is the ratio of the Exports(as % of merchandise exports) of Mexico in 2000 to that in 2013?
Your response must be concise. 1.56. What is the ratio of the Exports(as % of merchandise exports) of Nepal in 2000 to that in 2013?
Give a very brief answer. 0.15. What is the ratio of the Exports(as % of merchandise exports) in United Kingdom in 2000 to that in 2013?
Offer a terse response. 0.67. What is the ratio of the Exports(as % of merchandise exports) of OECD members in 2003 to that in 2009?
Your answer should be very brief. 1.19. What is the ratio of the Exports(as % of merchandise exports) in Mexico in 2003 to that in 2009?
Make the answer very short. 1.48. What is the ratio of the Exports(as % of merchandise exports) in Nepal in 2003 to that in 2009?
Provide a succinct answer. 0.37. What is the ratio of the Exports(as % of merchandise exports) of United Kingdom in 2003 to that in 2009?
Ensure brevity in your answer.  0.89. What is the ratio of the Exports(as % of merchandise exports) of OECD members in 2003 to that in 2010?
Your answer should be very brief. 1.08. What is the ratio of the Exports(as % of merchandise exports) of Mexico in 2003 to that in 2010?
Your answer should be very brief. 1.42. What is the ratio of the Exports(as % of merchandise exports) in Nepal in 2003 to that in 2010?
Your answer should be compact. 0.27. What is the ratio of the Exports(as % of merchandise exports) in United Kingdom in 2003 to that in 2010?
Provide a short and direct response. 0.8. What is the ratio of the Exports(as % of merchandise exports) in OECD members in 2003 to that in 2011?
Make the answer very short. 1.02. What is the ratio of the Exports(as % of merchandise exports) of Mexico in 2003 to that in 2011?
Your answer should be very brief. 1.35. What is the ratio of the Exports(as % of merchandise exports) of Nepal in 2003 to that in 2011?
Offer a terse response. 0.33. What is the ratio of the Exports(as % of merchandise exports) in United Kingdom in 2003 to that in 2011?
Your answer should be very brief. 0.77. What is the ratio of the Exports(as % of merchandise exports) in OECD members in 2003 to that in 2012?
Your response must be concise. 1.08. What is the ratio of the Exports(as % of merchandise exports) in Mexico in 2003 to that in 2012?
Make the answer very short. 1.32. What is the ratio of the Exports(as % of merchandise exports) of Nepal in 2003 to that in 2012?
Give a very brief answer. 0.33. What is the ratio of the Exports(as % of merchandise exports) of United Kingdom in 2003 to that in 2012?
Give a very brief answer. 0.76. What is the ratio of the Exports(as % of merchandise exports) in OECD members in 2003 to that in 2013?
Ensure brevity in your answer.  1.05. What is the ratio of the Exports(as % of merchandise exports) of Mexico in 2003 to that in 2013?
Ensure brevity in your answer.  1.44. What is the ratio of the Exports(as % of merchandise exports) of Nepal in 2003 to that in 2013?
Provide a succinct answer. 0.36. What is the ratio of the Exports(as % of merchandise exports) in United Kingdom in 2003 to that in 2013?
Your answer should be compact. 0.77. What is the ratio of the Exports(as % of merchandise exports) in OECD members in 2009 to that in 2010?
Your answer should be very brief. 0.91. What is the ratio of the Exports(as % of merchandise exports) in Mexico in 2009 to that in 2010?
Keep it short and to the point. 0.96. What is the ratio of the Exports(as % of merchandise exports) of Nepal in 2009 to that in 2010?
Provide a short and direct response. 0.74. What is the ratio of the Exports(as % of merchandise exports) in United Kingdom in 2009 to that in 2010?
Your response must be concise. 0.9. What is the ratio of the Exports(as % of merchandise exports) in OECD members in 2009 to that in 2011?
Your answer should be compact. 0.86. What is the ratio of the Exports(as % of merchandise exports) in Mexico in 2009 to that in 2011?
Keep it short and to the point. 0.91. What is the ratio of the Exports(as % of merchandise exports) of Nepal in 2009 to that in 2011?
Your response must be concise. 0.89. What is the ratio of the Exports(as % of merchandise exports) of United Kingdom in 2009 to that in 2011?
Give a very brief answer. 0.87. What is the ratio of the Exports(as % of merchandise exports) of OECD members in 2009 to that in 2012?
Provide a short and direct response. 0.91. What is the ratio of the Exports(as % of merchandise exports) in Mexico in 2009 to that in 2012?
Offer a terse response. 0.89. What is the ratio of the Exports(as % of merchandise exports) in Nepal in 2009 to that in 2012?
Give a very brief answer. 0.88. What is the ratio of the Exports(as % of merchandise exports) of United Kingdom in 2009 to that in 2012?
Give a very brief answer. 0.86. What is the ratio of the Exports(as % of merchandise exports) in OECD members in 2009 to that in 2013?
Keep it short and to the point. 0.89. What is the ratio of the Exports(as % of merchandise exports) of Mexico in 2009 to that in 2013?
Your answer should be compact. 0.97. What is the ratio of the Exports(as % of merchandise exports) of Nepal in 2009 to that in 2013?
Keep it short and to the point. 0.97. What is the ratio of the Exports(as % of merchandise exports) in United Kingdom in 2009 to that in 2013?
Your answer should be very brief. 0.87. What is the ratio of the Exports(as % of merchandise exports) of OECD members in 2010 to that in 2011?
Your answer should be very brief. 0.95. What is the ratio of the Exports(as % of merchandise exports) of Mexico in 2010 to that in 2011?
Make the answer very short. 0.95. What is the ratio of the Exports(as % of merchandise exports) in Nepal in 2010 to that in 2011?
Ensure brevity in your answer.  1.22. What is the ratio of the Exports(as % of merchandise exports) of United Kingdom in 2010 to that in 2011?
Give a very brief answer. 0.96. What is the ratio of the Exports(as % of merchandise exports) of OECD members in 2010 to that in 2012?
Your answer should be compact. 1. What is the ratio of the Exports(as % of merchandise exports) in Mexico in 2010 to that in 2012?
Ensure brevity in your answer.  0.93. What is the ratio of the Exports(as % of merchandise exports) in Nepal in 2010 to that in 2012?
Your answer should be compact. 1.19. What is the ratio of the Exports(as % of merchandise exports) of United Kingdom in 2010 to that in 2012?
Give a very brief answer. 0.95. What is the ratio of the Exports(as % of merchandise exports) in OECD members in 2010 to that in 2013?
Give a very brief answer. 0.98. What is the ratio of the Exports(as % of merchandise exports) in Mexico in 2010 to that in 2013?
Offer a very short reply. 1.02. What is the ratio of the Exports(as % of merchandise exports) of Nepal in 2010 to that in 2013?
Your answer should be compact. 1.31. What is the ratio of the Exports(as % of merchandise exports) of United Kingdom in 2010 to that in 2013?
Give a very brief answer. 0.96. What is the ratio of the Exports(as % of merchandise exports) in OECD members in 2011 to that in 2012?
Provide a succinct answer. 1.06. What is the ratio of the Exports(as % of merchandise exports) of Mexico in 2011 to that in 2012?
Offer a very short reply. 0.98. What is the ratio of the Exports(as % of merchandise exports) in Nepal in 2011 to that in 2012?
Your answer should be compact. 0.98. What is the ratio of the Exports(as % of merchandise exports) in United Kingdom in 2011 to that in 2012?
Offer a very short reply. 0.99. What is the ratio of the Exports(as % of merchandise exports) in OECD members in 2011 to that in 2013?
Your answer should be very brief. 1.03. What is the ratio of the Exports(as % of merchandise exports) in Mexico in 2011 to that in 2013?
Your answer should be compact. 1.07. What is the ratio of the Exports(as % of merchandise exports) in Nepal in 2011 to that in 2013?
Provide a succinct answer. 1.08. What is the ratio of the Exports(as % of merchandise exports) of United Kingdom in 2011 to that in 2013?
Offer a very short reply. 1. What is the ratio of the Exports(as % of merchandise exports) in Mexico in 2012 to that in 2013?
Keep it short and to the point. 1.09. What is the ratio of the Exports(as % of merchandise exports) of Nepal in 2012 to that in 2013?
Keep it short and to the point. 1.1. What is the difference between the highest and the second highest Exports(as % of merchandise exports) of OECD members?
Your answer should be very brief. 0.11. What is the difference between the highest and the second highest Exports(as % of merchandise exports) in Mexico?
Make the answer very short. 0.04. What is the difference between the highest and the second highest Exports(as % of merchandise exports) in Nepal?
Your response must be concise. 0.63. What is the difference between the highest and the second highest Exports(as % of merchandise exports) in United Kingdom?
Give a very brief answer. 0. What is the difference between the highest and the lowest Exports(as % of merchandise exports) in OECD members?
Keep it short and to the point. 0.38. What is the difference between the highest and the lowest Exports(as % of merchandise exports) in Mexico?
Your response must be concise. 0.21. What is the difference between the highest and the lowest Exports(as % of merchandise exports) of Nepal?
Your answer should be compact. 3.48. What is the difference between the highest and the lowest Exports(as % of merchandise exports) in United Kingdom?
Your answer should be very brief. 0.24. 